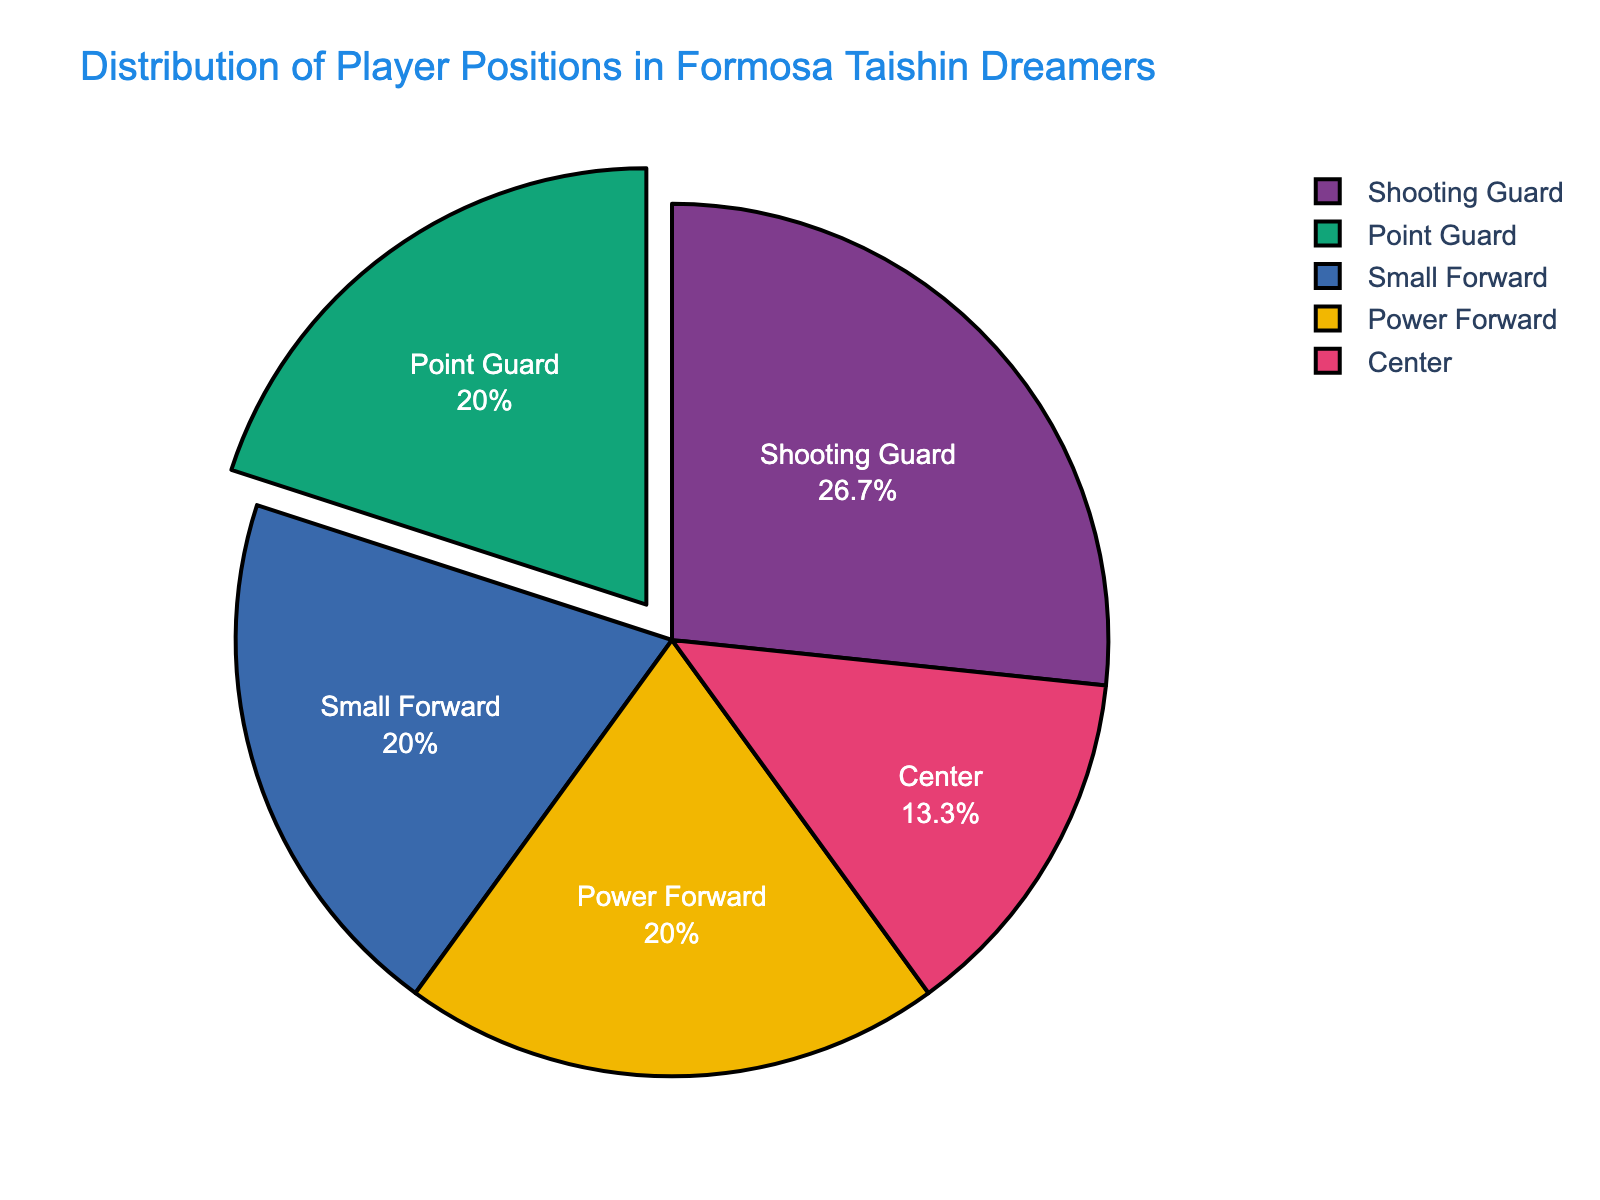Which position has the largest number of players? The pie chart shows different player positions and their proportions. The largest slice represents Shooting Guard with 4 players.
Answer: Shooting Guard How many more Shooting Guards are there compared to Centers? The number of Shooting Guards is 4, and the number of Centers is 2. The difference is 4 - 2 = 2.
Answer: 2 Which positions have an equal number of players? The pie chart indicates that Point Guard, Small Forward, and Power Forward each have 3 players.
Answer: Point Guard, Small Forward, Power Forward What is the total percentage of players who are either Small Forwards or Power Forwards? Each position (Small Forward and Power Forward) has an equal number of players (3 each). The total number of players is 15. Hence, (3/15 + 3/15) * 100 = 20 + 20 = 40%.
Answer: 40% By what percentage does the number of Shooting Guards exceed the number of Centers? Shooting Guards: 4 players, Centers: 2 players. The difference is 4 - 2 = 2. The percentage excess is (2 / 2) * 100% = 100%.
Answer: 100% Which position is visually distinct by a pulled-out slice in the pie chart? The pie chart’s design visually pulls out one segment to highlight it. The pulled-out slice is for Point Guard.
Answer: Point Guard What is the approximate percentage of players who are Point Guards? Point Guards: 3 players out of 15. The percentage is (3 / 15) * 100 = 20%.
Answer: 20% Calculate the total number of players from the average number of players per position. There are 5 positions. Total players: 15. Average per position: 15 / 5 = 3. Hence, the total is 3 * 5 = 15.
Answer: 15 